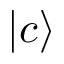<formula> <loc_0><loc_0><loc_500><loc_500>| c \rangle</formula> 